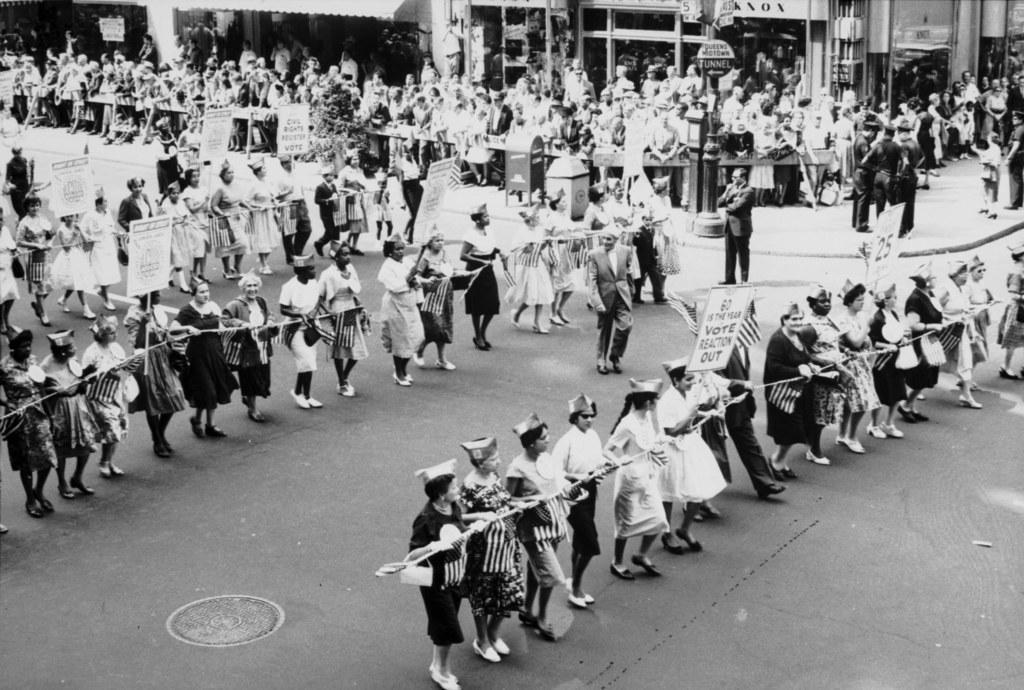Could you give a brief overview of what you see in this image? This is a black and white image. In this image we can see there are people holding objects. Among them few people are holding boards. There are stores. 